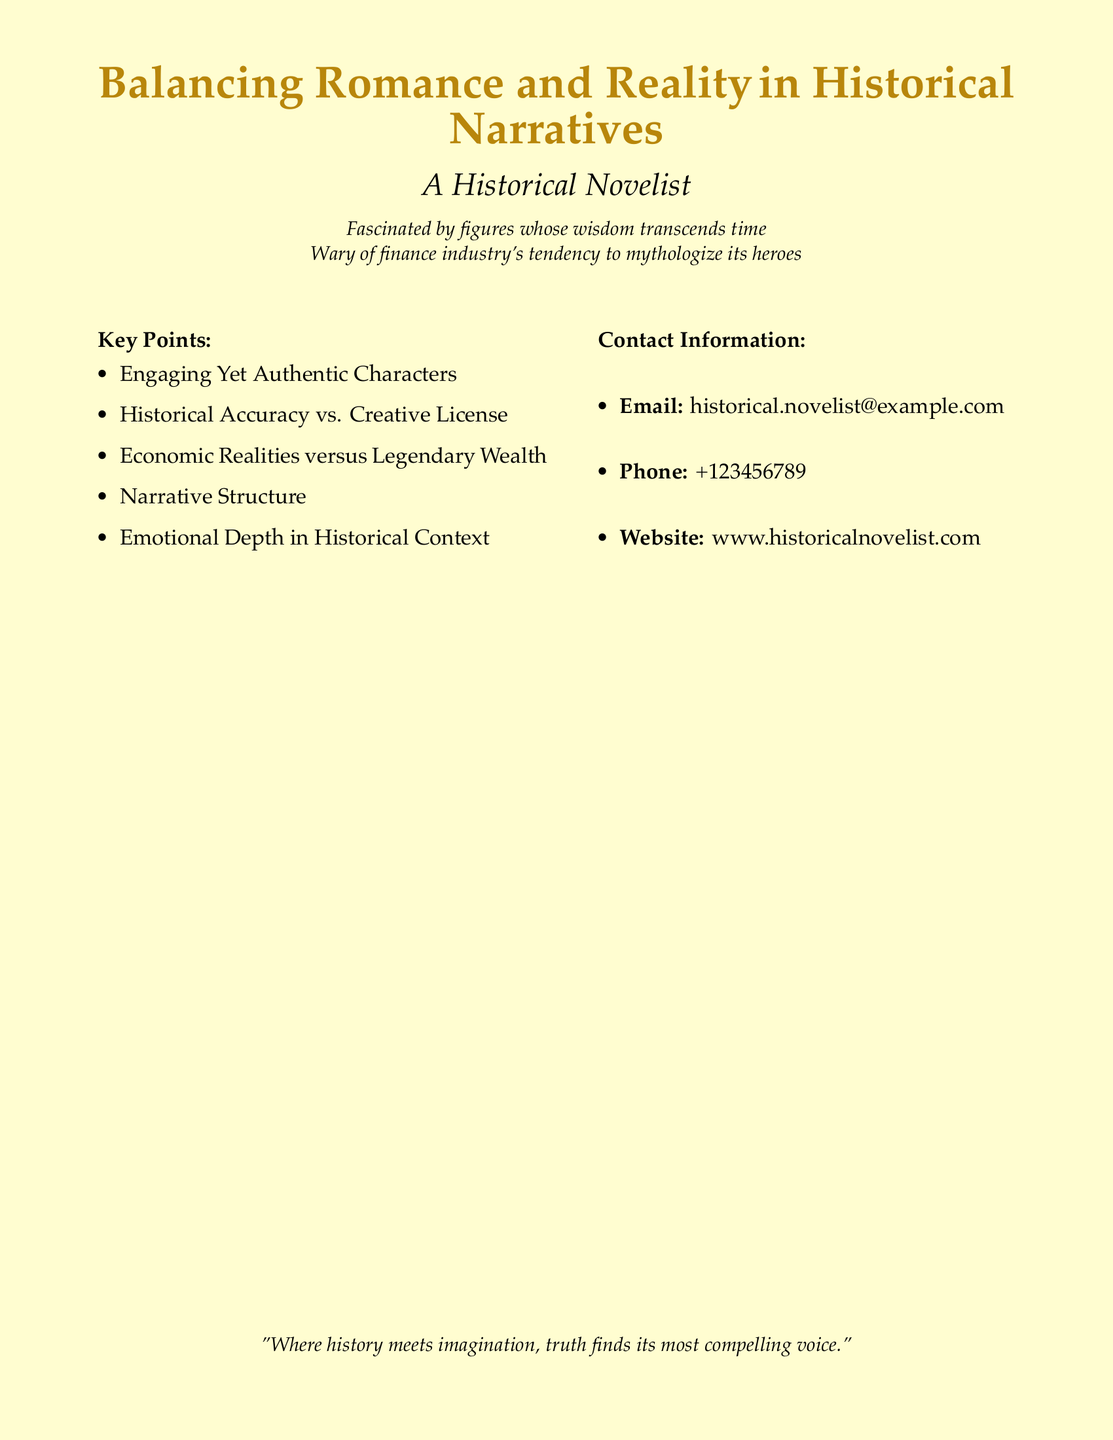What is the primary focus of the document? The document centers on the theme of balancing romance and reality in the context of historical narratives.
Answer: Balancing Romance and Reality Who is the intended audience for the document? The intended audience appears to be individuals interested in historical novels, especially those who appreciate authenticity in narratives.
Answer: A Historical Novelist What type of characters does the document highlight? The document emphasizes the importance of characters that are both engaging and authentic.
Answer: Engaging Yet Authentic Characters What is the email address provided in the contact information? The email address listed for contact is a key piece of information.
Answer: historical.novelist@example.com What is the website for more information? The website given in the document allows for further inquiry into the author’s work.
Answer: www.historicalnovelist.com Which aspect contrasts historical accuracy in narratives? The document discusses the tension between historical accuracy and creative license, presenting a key point of consideration.
Answer: Creative License How many key points are listed in the document? The document contains a total of five key points related to historical narratives.
Answer: Five What does the author criticize about the finance industry? The document indicates a specific critique regarding the mythologization of heroes by the finance industry.
Answer: Mythologize its heroes What quote is included at the end of the document? The quote serves as a summary reflection on the overlap of history and imagination.
Answer: "Where history meets imagination, truth finds its most compelling voice." 